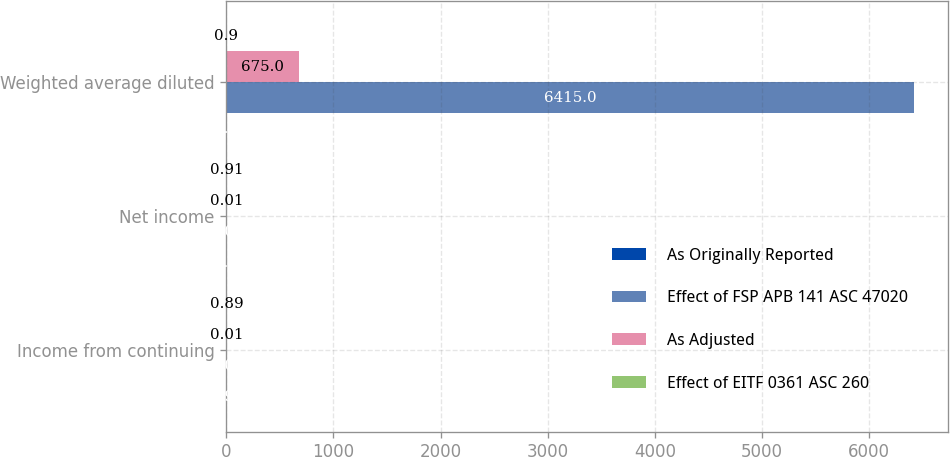Convert chart to OTSL. <chart><loc_0><loc_0><loc_500><loc_500><stacked_bar_chart><ecel><fcel>Income from continuing<fcel>Net income<fcel>Weighted average diluted<nl><fcel>As Originally Reported<fcel>0.98<fcel>1<fcel>0.9<nl><fcel>Effect of FSP APB 141 ASC 47020<fcel>0.08<fcel>0.08<fcel>6415<nl><fcel>As Adjusted<fcel>0.01<fcel>0.01<fcel>675<nl><fcel>Effect of EITF 0361 ASC 260<fcel>0.89<fcel>0.91<fcel>0.9<nl></chart> 